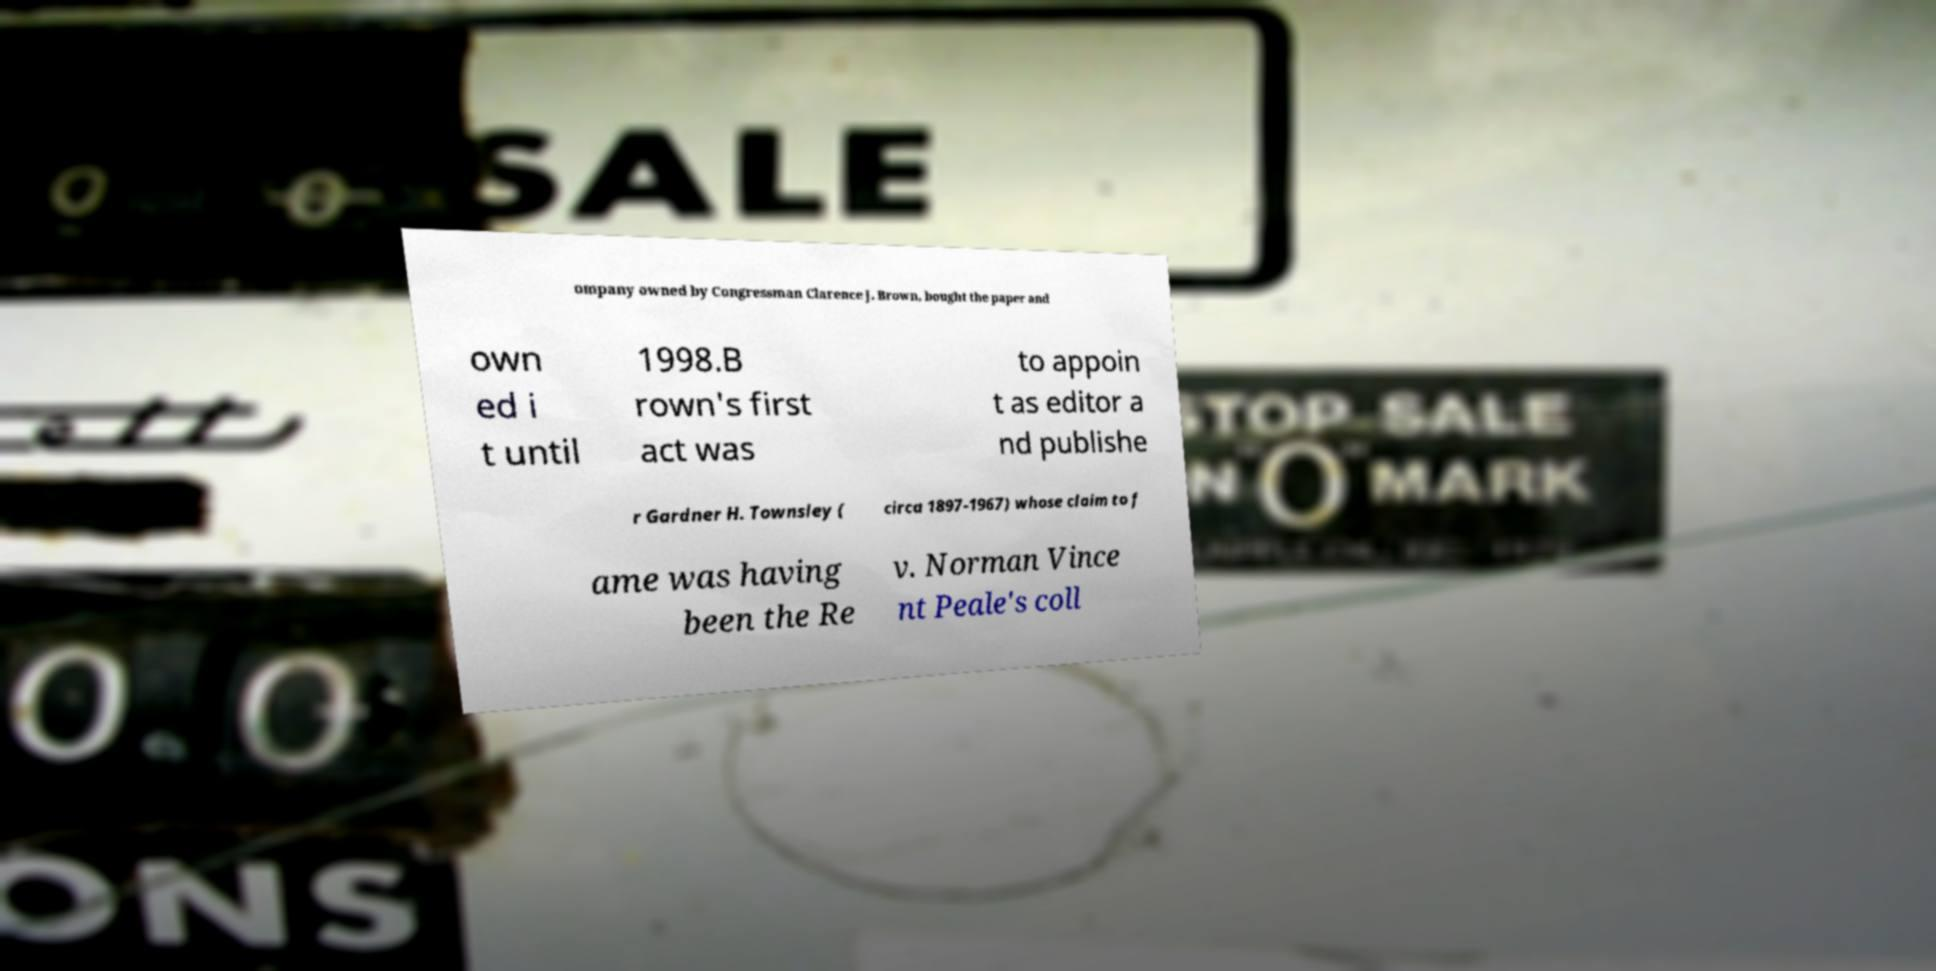Can you read and provide the text displayed in the image?This photo seems to have some interesting text. Can you extract and type it out for me? ompany owned by Congressman Clarence J. Brown, bought the paper and own ed i t until 1998.B rown's first act was to appoin t as editor a nd publishe r Gardner H. Townsley ( circa 1897-1967) whose claim to f ame was having been the Re v. Norman Vince nt Peale's coll 